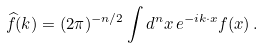<formula> <loc_0><loc_0><loc_500><loc_500>\widehat { f } ( k ) = ( 2 \pi ) ^ { - n / 2 } \int d ^ { n } x \, e ^ { - i k \cdot x } f ( x ) \, .</formula> 